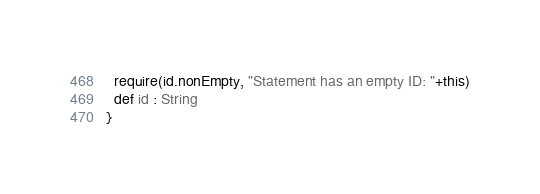<code> <loc_0><loc_0><loc_500><loc_500><_Scala_>  require(id.nonEmpty, "Statement has an empty ID: "+this)
  def id : String
}
</code> 